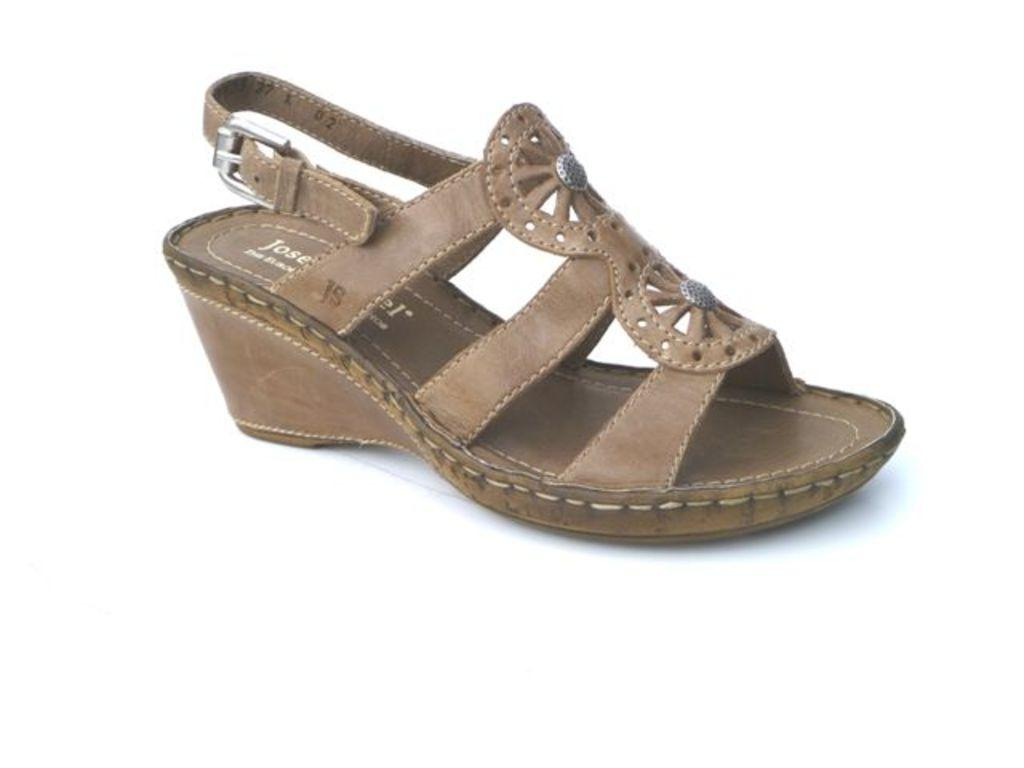What type of footwear is visible in the image? There is a pair of ladies' footwear in the image. What type of chain is attached to the ladies' footwear in the image? There is no chain attached to the ladies' footwear in the image. 